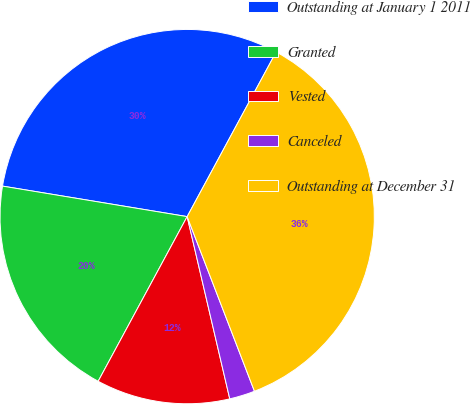Convert chart to OTSL. <chart><loc_0><loc_0><loc_500><loc_500><pie_chart><fcel>Outstanding at January 1 2011<fcel>Granted<fcel>Vested<fcel>Canceled<fcel>Outstanding at December 31<nl><fcel>30.28%<fcel>19.72%<fcel>11.54%<fcel>2.2%<fcel>36.26%<nl></chart> 